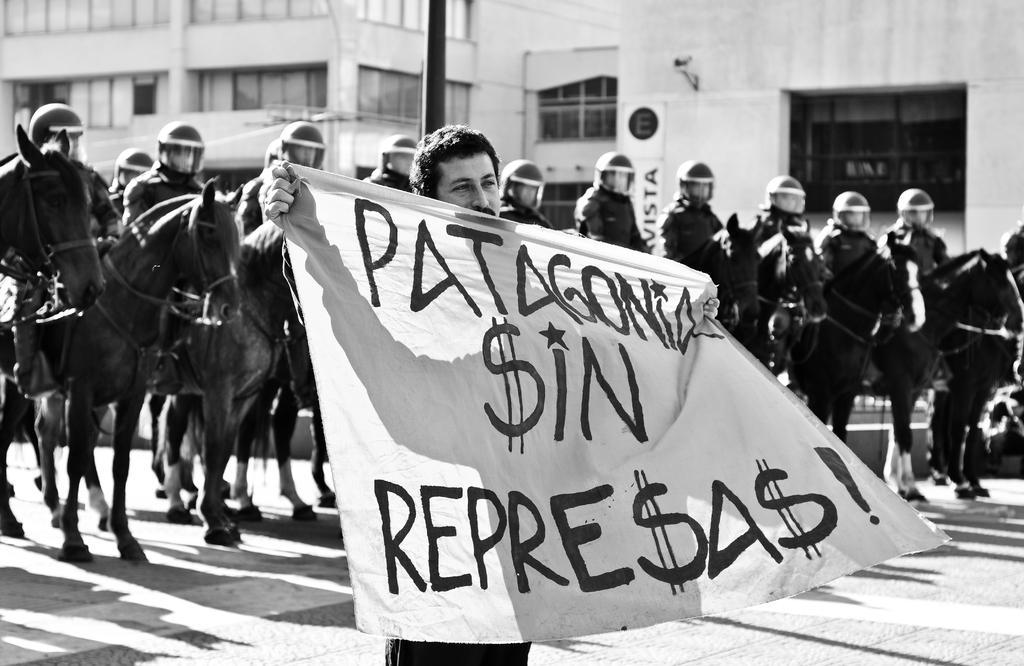Please provide a concise description of this image. As we can see in the image, there are buildings, a window, few people sitting on horses and the man who is standing in the front is holding banner. 